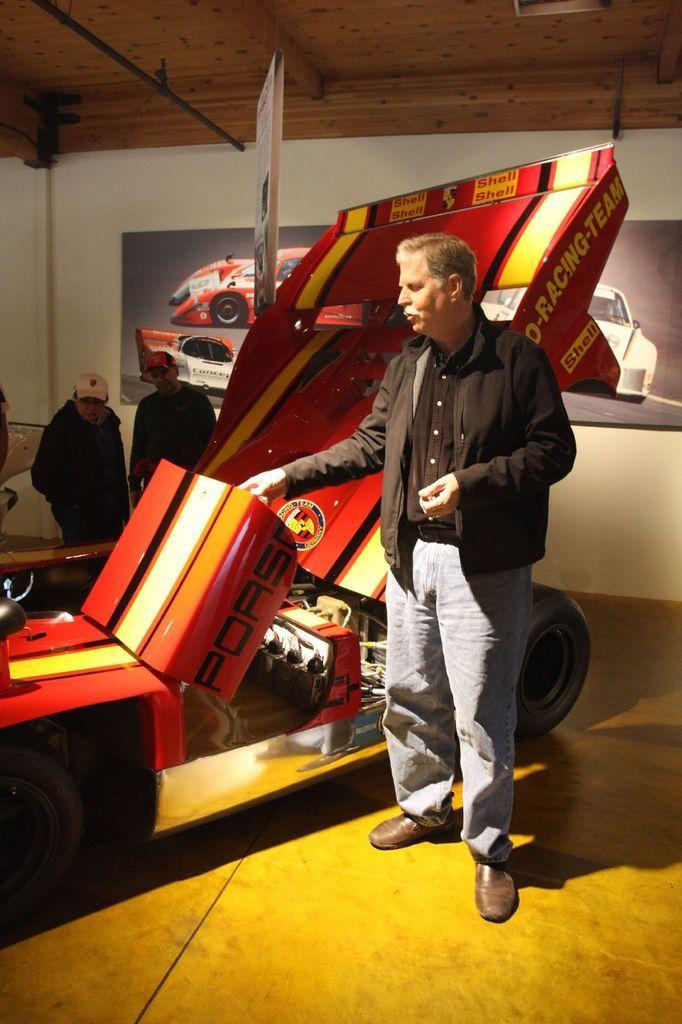Please provide a concise description of this image. In the picture we can see a man standing on the floor near the sports vehicle which is red in color with some brand names on it and in the background, we can see two people are standing with caps and to the wall we can see a poster with some car images on it and to the ceiling is with wood. 